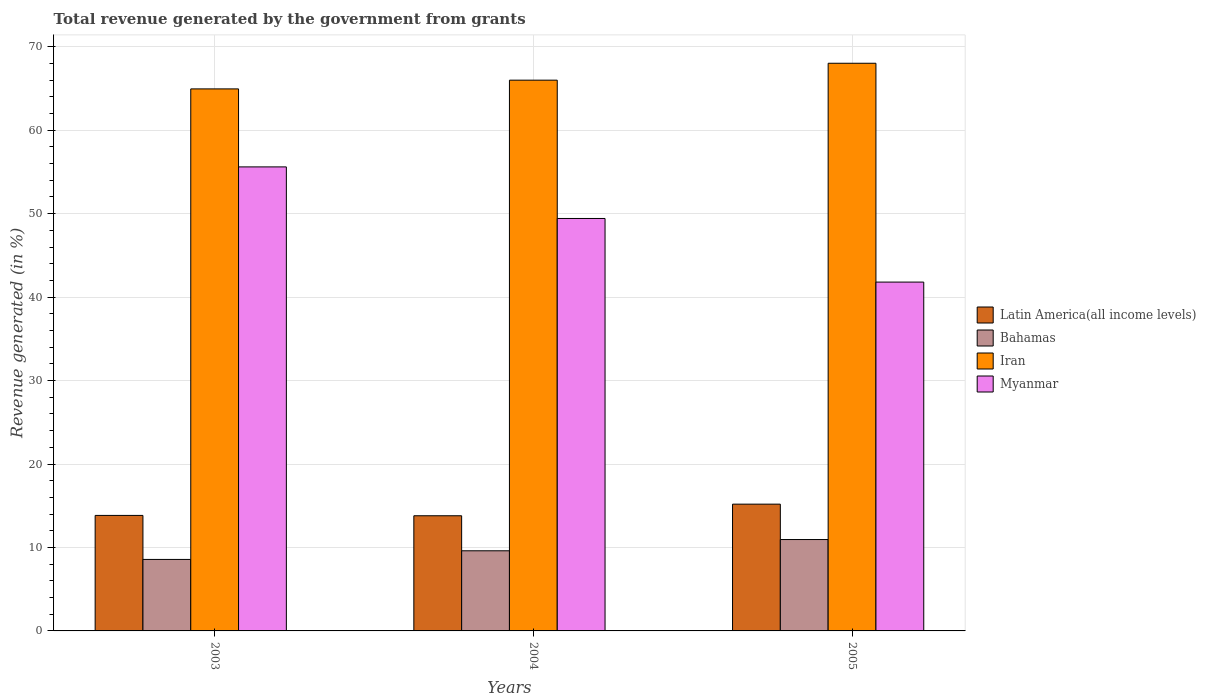Are the number of bars per tick equal to the number of legend labels?
Keep it short and to the point. Yes. How many bars are there on the 2nd tick from the left?
Your response must be concise. 4. How many bars are there on the 1st tick from the right?
Keep it short and to the point. 4. What is the label of the 2nd group of bars from the left?
Your response must be concise. 2004. What is the total revenue generated in Myanmar in 2004?
Make the answer very short. 49.43. Across all years, what is the maximum total revenue generated in Latin America(all income levels)?
Keep it short and to the point. 15.19. Across all years, what is the minimum total revenue generated in Iran?
Your answer should be very brief. 64.95. In which year was the total revenue generated in Iran maximum?
Offer a terse response. 2005. In which year was the total revenue generated in Iran minimum?
Your response must be concise. 2003. What is the total total revenue generated in Iran in the graph?
Make the answer very short. 198.98. What is the difference between the total revenue generated in Latin America(all income levels) in 2003 and that in 2005?
Your answer should be compact. -1.35. What is the difference between the total revenue generated in Bahamas in 2003 and the total revenue generated in Latin America(all income levels) in 2004?
Make the answer very short. -5.23. What is the average total revenue generated in Latin America(all income levels) per year?
Your response must be concise. 14.28. In the year 2003, what is the difference between the total revenue generated in Myanmar and total revenue generated in Iran?
Make the answer very short. -9.35. What is the ratio of the total revenue generated in Bahamas in 2004 to that in 2005?
Your answer should be very brief. 0.88. Is the total revenue generated in Bahamas in 2004 less than that in 2005?
Offer a very short reply. Yes. Is the difference between the total revenue generated in Myanmar in 2003 and 2005 greater than the difference between the total revenue generated in Iran in 2003 and 2005?
Provide a short and direct response. Yes. What is the difference between the highest and the second highest total revenue generated in Latin America(all income levels)?
Provide a short and direct response. 1.35. What is the difference between the highest and the lowest total revenue generated in Bahamas?
Provide a succinct answer. 2.38. In how many years, is the total revenue generated in Iran greater than the average total revenue generated in Iran taken over all years?
Offer a terse response. 1. Is the sum of the total revenue generated in Bahamas in 2003 and 2004 greater than the maximum total revenue generated in Iran across all years?
Provide a succinct answer. No. Is it the case that in every year, the sum of the total revenue generated in Myanmar and total revenue generated in Iran is greater than the sum of total revenue generated in Latin America(all income levels) and total revenue generated in Bahamas?
Offer a terse response. No. What does the 4th bar from the left in 2003 represents?
Give a very brief answer. Myanmar. What does the 2nd bar from the right in 2003 represents?
Your response must be concise. Iran. Is it the case that in every year, the sum of the total revenue generated in Myanmar and total revenue generated in Latin America(all income levels) is greater than the total revenue generated in Bahamas?
Offer a very short reply. Yes. Are all the bars in the graph horizontal?
Give a very brief answer. No. How many years are there in the graph?
Offer a terse response. 3. What is the difference between two consecutive major ticks on the Y-axis?
Ensure brevity in your answer.  10. Are the values on the major ticks of Y-axis written in scientific E-notation?
Provide a succinct answer. No. Does the graph contain grids?
Your answer should be compact. Yes. Where does the legend appear in the graph?
Your answer should be compact. Center right. How many legend labels are there?
Your answer should be compact. 4. What is the title of the graph?
Make the answer very short. Total revenue generated by the government from grants. What is the label or title of the Y-axis?
Provide a short and direct response. Revenue generated (in %). What is the Revenue generated (in %) in Latin America(all income levels) in 2003?
Offer a terse response. 13.84. What is the Revenue generated (in %) of Bahamas in 2003?
Provide a short and direct response. 8.57. What is the Revenue generated (in %) of Iran in 2003?
Your answer should be very brief. 64.95. What is the Revenue generated (in %) of Myanmar in 2003?
Offer a very short reply. 55.61. What is the Revenue generated (in %) of Latin America(all income levels) in 2004?
Offer a terse response. 13.8. What is the Revenue generated (in %) in Bahamas in 2004?
Offer a terse response. 9.6. What is the Revenue generated (in %) of Iran in 2004?
Give a very brief answer. 66. What is the Revenue generated (in %) in Myanmar in 2004?
Ensure brevity in your answer.  49.43. What is the Revenue generated (in %) in Latin America(all income levels) in 2005?
Ensure brevity in your answer.  15.19. What is the Revenue generated (in %) in Bahamas in 2005?
Your answer should be compact. 10.95. What is the Revenue generated (in %) of Iran in 2005?
Your response must be concise. 68.03. What is the Revenue generated (in %) of Myanmar in 2005?
Keep it short and to the point. 41.8. Across all years, what is the maximum Revenue generated (in %) in Latin America(all income levels)?
Make the answer very short. 15.19. Across all years, what is the maximum Revenue generated (in %) of Bahamas?
Ensure brevity in your answer.  10.95. Across all years, what is the maximum Revenue generated (in %) of Iran?
Your answer should be very brief. 68.03. Across all years, what is the maximum Revenue generated (in %) of Myanmar?
Your response must be concise. 55.61. Across all years, what is the minimum Revenue generated (in %) of Latin America(all income levels)?
Your response must be concise. 13.8. Across all years, what is the minimum Revenue generated (in %) of Bahamas?
Give a very brief answer. 8.57. Across all years, what is the minimum Revenue generated (in %) in Iran?
Make the answer very short. 64.95. Across all years, what is the minimum Revenue generated (in %) of Myanmar?
Make the answer very short. 41.8. What is the total Revenue generated (in %) in Latin America(all income levels) in the graph?
Your answer should be compact. 42.84. What is the total Revenue generated (in %) of Bahamas in the graph?
Keep it short and to the point. 29.12. What is the total Revenue generated (in %) of Iran in the graph?
Your answer should be compact. 198.98. What is the total Revenue generated (in %) in Myanmar in the graph?
Your answer should be very brief. 146.84. What is the difference between the Revenue generated (in %) in Latin America(all income levels) in 2003 and that in 2004?
Offer a very short reply. 0.04. What is the difference between the Revenue generated (in %) in Bahamas in 2003 and that in 2004?
Make the answer very short. -1.04. What is the difference between the Revenue generated (in %) of Iran in 2003 and that in 2004?
Keep it short and to the point. -1.05. What is the difference between the Revenue generated (in %) of Myanmar in 2003 and that in 2004?
Make the answer very short. 6.18. What is the difference between the Revenue generated (in %) in Latin America(all income levels) in 2003 and that in 2005?
Give a very brief answer. -1.35. What is the difference between the Revenue generated (in %) in Bahamas in 2003 and that in 2005?
Provide a succinct answer. -2.38. What is the difference between the Revenue generated (in %) of Iran in 2003 and that in 2005?
Provide a short and direct response. -3.07. What is the difference between the Revenue generated (in %) of Myanmar in 2003 and that in 2005?
Your answer should be very brief. 13.8. What is the difference between the Revenue generated (in %) of Latin America(all income levels) in 2004 and that in 2005?
Make the answer very short. -1.39. What is the difference between the Revenue generated (in %) in Bahamas in 2004 and that in 2005?
Offer a terse response. -1.35. What is the difference between the Revenue generated (in %) in Iran in 2004 and that in 2005?
Keep it short and to the point. -2.03. What is the difference between the Revenue generated (in %) in Myanmar in 2004 and that in 2005?
Offer a terse response. 7.62. What is the difference between the Revenue generated (in %) in Latin America(all income levels) in 2003 and the Revenue generated (in %) in Bahamas in 2004?
Offer a very short reply. 4.24. What is the difference between the Revenue generated (in %) in Latin America(all income levels) in 2003 and the Revenue generated (in %) in Iran in 2004?
Make the answer very short. -52.16. What is the difference between the Revenue generated (in %) of Latin America(all income levels) in 2003 and the Revenue generated (in %) of Myanmar in 2004?
Make the answer very short. -35.58. What is the difference between the Revenue generated (in %) of Bahamas in 2003 and the Revenue generated (in %) of Iran in 2004?
Your answer should be very brief. -57.43. What is the difference between the Revenue generated (in %) in Bahamas in 2003 and the Revenue generated (in %) in Myanmar in 2004?
Make the answer very short. -40.86. What is the difference between the Revenue generated (in %) of Iran in 2003 and the Revenue generated (in %) of Myanmar in 2004?
Give a very brief answer. 15.53. What is the difference between the Revenue generated (in %) of Latin America(all income levels) in 2003 and the Revenue generated (in %) of Bahamas in 2005?
Provide a succinct answer. 2.89. What is the difference between the Revenue generated (in %) of Latin America(all income levels) in 2003 and the Revenue generated (in %) of Iran in 2005?
Provide a short and direct response. -54.19. What is the difference between the Revenue generated (in %) of Latin America(all income levels) in 2003 and the Revenue generated (in %) of Myanmar in 2005?
Give a very brief answer. -27.96. What is the difference between the Revenue generated (in %) in Bahamas in 2003 and the Revenue generated (in %) in Iran in 2005?
Provide a short and direct response. -59.46. What is the difference between the Revenue generated (in %) of Bahamas in 2003 and the Revenue generated (in %) of Myanmar in 2005?
Provide a short and direct response. -33.24. What is the difference between the Revenue generated (in %) of Iran in 2003 and the Revenue generated (in %) of Myanmar in 2005?
Provide a succinct answer. 23.15. What is the difference between the Revenue generated (in %) of Latin America(all income levels) in 2004 and the Revenue generated (in %) of Bahamas in 2005?
Ensure brevity in your answer.  2.85. What is the difference between the Revenue generated (in %) of Latin America(all income levels) in 2004 and the Revenue generated (in %) of Iran in 2005?
Make the answer very short. -54.23. What is the difference between the Revenue generated (in %) of Latin America(all income levels) in 2004 and the Revenue generated (in %) of Myanmar in 2005?
Your response must be concise. -28. What is the difference between the Revenue generated (in %) of Bahamas in 2004 and the Revenue generated (in %) of Iran in 2005?
Offer a terse response. -58.42. What is the difference between the Revenue generated (in %) of Bahamas in 2004 and the Revenue generated (in %) of Myanmar in 2005?
Provide a short and direct response. -32.2. What is the difference between the Revenue generated (in %) of Iran in 2004 and the Revenue generated (in %) of Myanmar in 2005?
Your answer should be compact. 24.2. What is the average Revenue generated (in %) in Latin America(all income levels) per year?
Offer a terse response. 14.28. What is the average Revenue generated (in %) in Bahamas per year?
Keep it short and to the point. 9.71. What is the average Revenue generated (in %) of Iran per year?
Provide a short and direct response. 66.33. What is the average Revenue generated (in %) of Myanmar per year?
Offer a very short reply. 48.95. In the year 2003, what is the difference between the Revenue generated (in %) of Latin America(all income levels) and Revenue generated (in %) of Bahamas?
Make the answer very short. 5.27. In the year 2003, what is the difference between the Revenue generated (in %) of Latin America(all income levels) and Revenue generated (in %) of Iran?
Give a very brief answer. -51.11. In the year 2003, what is the difference between the Revenue generated (in %) in Latin America(all income levels) and Revenue generated (in %) in Myanmar?
Provide a succinct answer. -41.76. In the year 2003, what is the difference between the Revenue generated (in %) of Bahamas and Revenue generated (in %) of Iran?
Offer a terse response. -56.39. In the year 2003, what is the difference between the Revenue generated (in %) in Bahamas and Revenue generated (in %) in Myanmar?
Ensure brevity in your answer.  -47.04. In the year 2003, what is the difference between the Revenue generated (in %) in Iran and Revenue generated (in %) in Myanmar?
Your response must be concise. 9.35. In the year 2004, what is the difference between the Revenue generated (in %) in Latin America(all income levels) and Revenue generated (in %) in Bahamas?
Make the answer very short. 4.2. In the year 2004, what is the difference between the Revenue generated (in %) of Latin America(all income levels) and Revenue generated (in %) of Iran?
Your answer should be compact. -52.2. In the year 2004, what is the difference between the Revenue generated (in %) of Latin America(all income levels) and Revenue generated (in %) of Myanmar?
Offer a terse response. -35.62. In the year 2004, what is the difference between the Revenue generated (in %) of Bahamas and Revenue generated (in %) of Iran?
Give a very brief answer. -56.4. In the year 2004, what is the difference between the Revenue generated (in %) in Bahamas and Revenue generated (in %) in Myanmar?
Offer a terse response. -39.82. In the year 2004, what is the difference between the Revenue generated (in %) in Iran and Revenue generated (in %) in Myanmar?
Your response must be concise. 16.58. In the year 2005, what is the difference between the Revenue generated (in %) in Latin America(all income levels) and Revenue generated (in %) in Bahamas?
Ensure brevity in your answer.  4.24. In the year 2005, what is the difference between the Revenue generated (in %) in Latin America(all income levels) and Revenue generated (in %) in Iran?
Make the answer very short. -52.83. In the year 2005, what is the difference between the Revenue generated (in %) of Latin America(all income levels) and Revenue generated (in %) of Myanmar?
Your response must be concise. -26.61. In the year 2005, what is the difference between the Revenue generated (in %) of Bahamas and Revenue generated (in %) of Iran?
Your response must be concise. -57.08. In the year 2005, what is the difference between the Revenue generated (in %) of Bahamas and Revenue generated (in %) of Myanmar?
Your answer should be very brief. -30.85. In the year 2005, what is the difference between the Revenue generated (in %) in Iran and Revenue generated (in %) in Myanmar?
Make the answer very short. 26.22. What is the ratio of the Revenue generated (in %) in Latin America(all income levels) in 2003 to that in 2004?
Your answer should be compact. 1. What is the ratio of the Revenue generated (in %) in Bahamas in 2003 to that in 2004?
Make the answer very short. 0.89. What is the ratio of the Revenue generated (in %) of Iran in 2003 to that in 2004?
Offer a very short reply. 0.98. What is the ratio of the Revenue generated (in %) of Latin America(all income levels) in 2003 to that in 2005?
Provide a short and direct response. 0.91. What is the ratio of the Revenue generated (in %) in Bahamas in 2003 to that in 2005?
Offer a very short reply. 0.78. What is the ratio of the Revenue generated (in %) of Iran in 2003 to that in 2005?
Offer a very short reply. 0.95. What is the ratio of the Revenue generated (in %) in Myanmar in 2003 to that in 2005?
Make the answer very short. 1.33. What is the ratio of the Revenue generated (in %) in Latin America(all income levels) in 2004 to that in 2005?
Provide a short and direct response. 0.91. What is the ratio of the Revenue generated (in %) in Bahamas in 2004 to that in 2005?
Your answer should be compact. 0.88. What is the ratio of the Revenue generated (in %) of Iran in 2004 to that in 2005?
Provide a short and direct response. 0.97. What is the ratio of the Revenue generated (in %) in Myanmar in 2004 to that in 2005?
Give a very brief answer. 1.18. What is the difference between the highest and the second highest Revenue generated (in %) of Latin America(all income levels)?
Ensure brevity in your answer.  1.35. What is the difference between the highest and the second highest Revenue generated (in %) of Bahamas?
Ensure brevity in your answer.  1.35. What is the difference between the highest and the second highest Revenue generated (in %) of Iran?
Your answer should be compact. 2.03. What is the difference between the highest and the second highest Revenue generated (in %) of Myanmar?
Make the answer very short. 6.18. What is the difference between the highest and the lowest Revenue generated (in %) in Latin America(all income levels)?
Give a very brief answer. 1.39. What is the difference between the highest and the lowest Revenue generated (in %) in Bahamas?
Ensure brevity in your answer.  2.38. What is the difference between the highest and the lowest Revenue generated (in %) of Iran?
Ensure brevity in your answer.  3.07. What is the difference between the highest and the lowest Revenue generated (in %) of Myanmar?
Your answer should be compact. 13.8. 